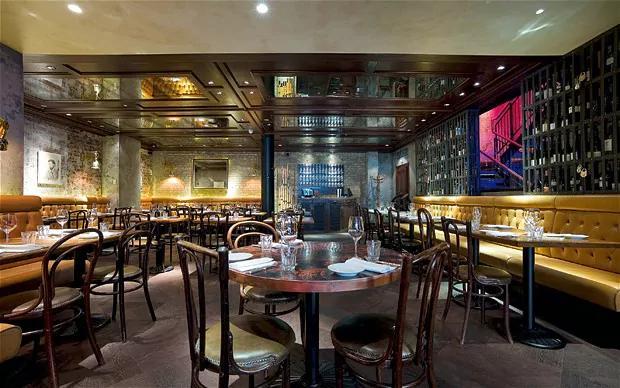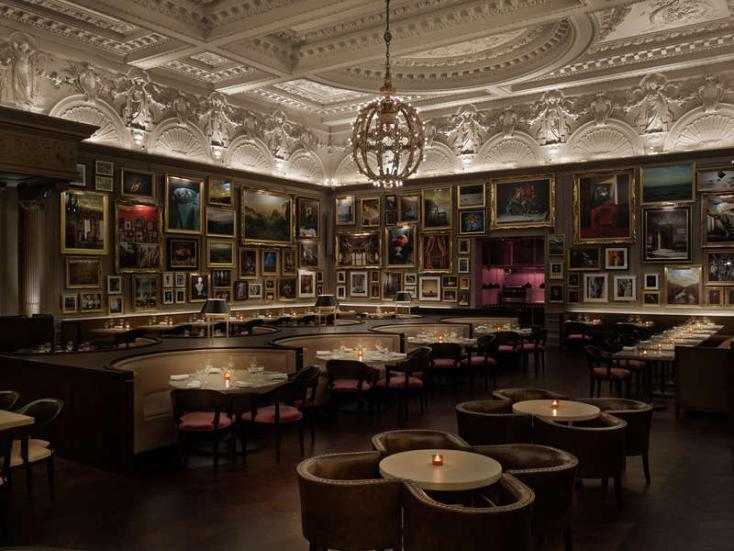The first image is the image on the left, the second image is the image on the right. Given the left and right images, does the statement "An interior of a restaurant has yellow tufted bench seating around its perimeter and has a view of a staircase glowing violet and blue above the seating on the right." hold true? Answer yes or no. Yes. The first image is the image on the left, the second image is the image on the right. Considering the images on both sides, is "Each image shows an empty restaurant with no people visible." valid? Answer yes or no. Yes. 